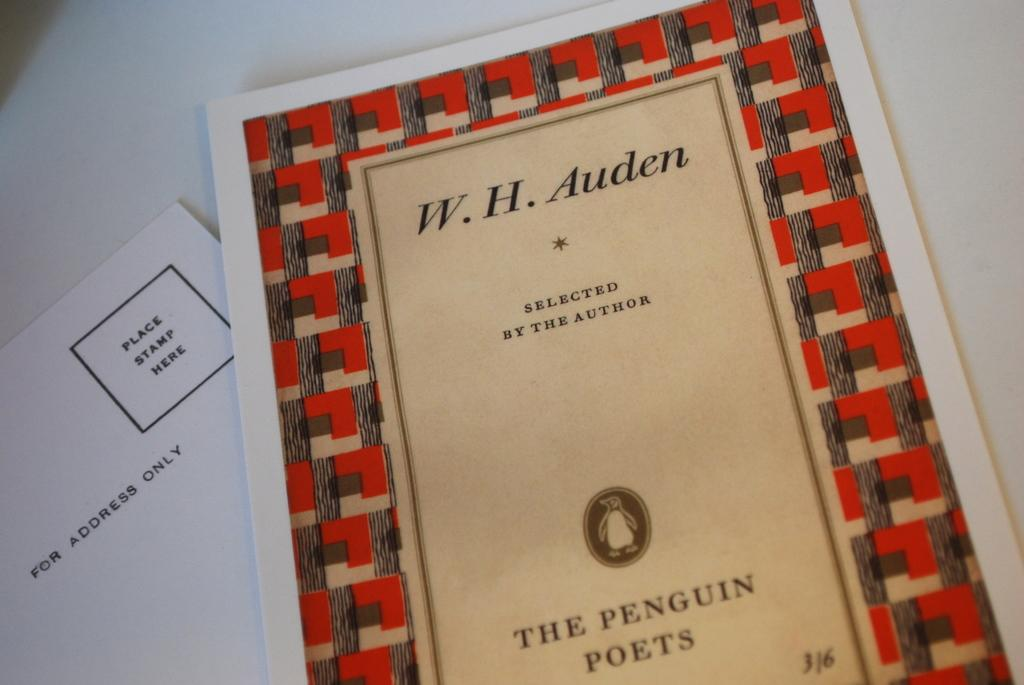<image>
Provide a brief description of the given image. W.H.Auden the Penguin Poets place stamp here lying on a white table. 